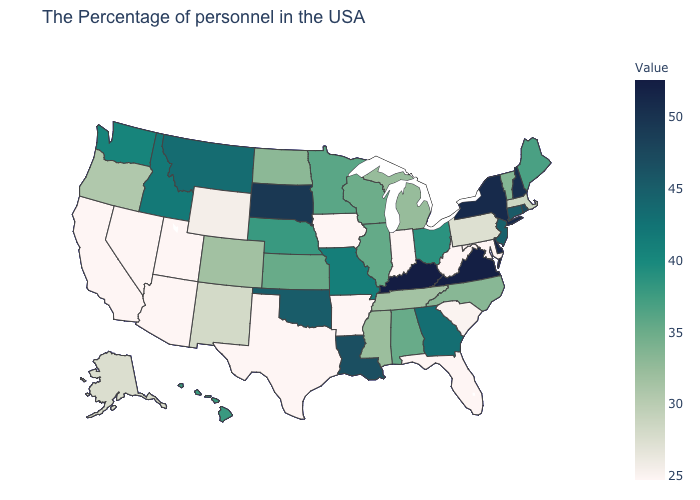Which states have the highest value in the USA?
Answer briefly. Kentucky. Among the states that border New Jersey , which have the lowest value?
Be succinct. Pennsylvania. Which states have the lowest value in the Northeast?
Concise answer only. Pennsylvania. Which states hav the highest value in the South?
Write a very short answer. Kentucky. Is the legend a continuous bar?
Keep it brief. Yes. Which states hav the highest value in the West?
Give a very brief answer. Montana. Does the map have missing data?
Concise answer only. No. Among the states that border Connecticut , does Rhode Island have the highest value?
Short answer required. No. 